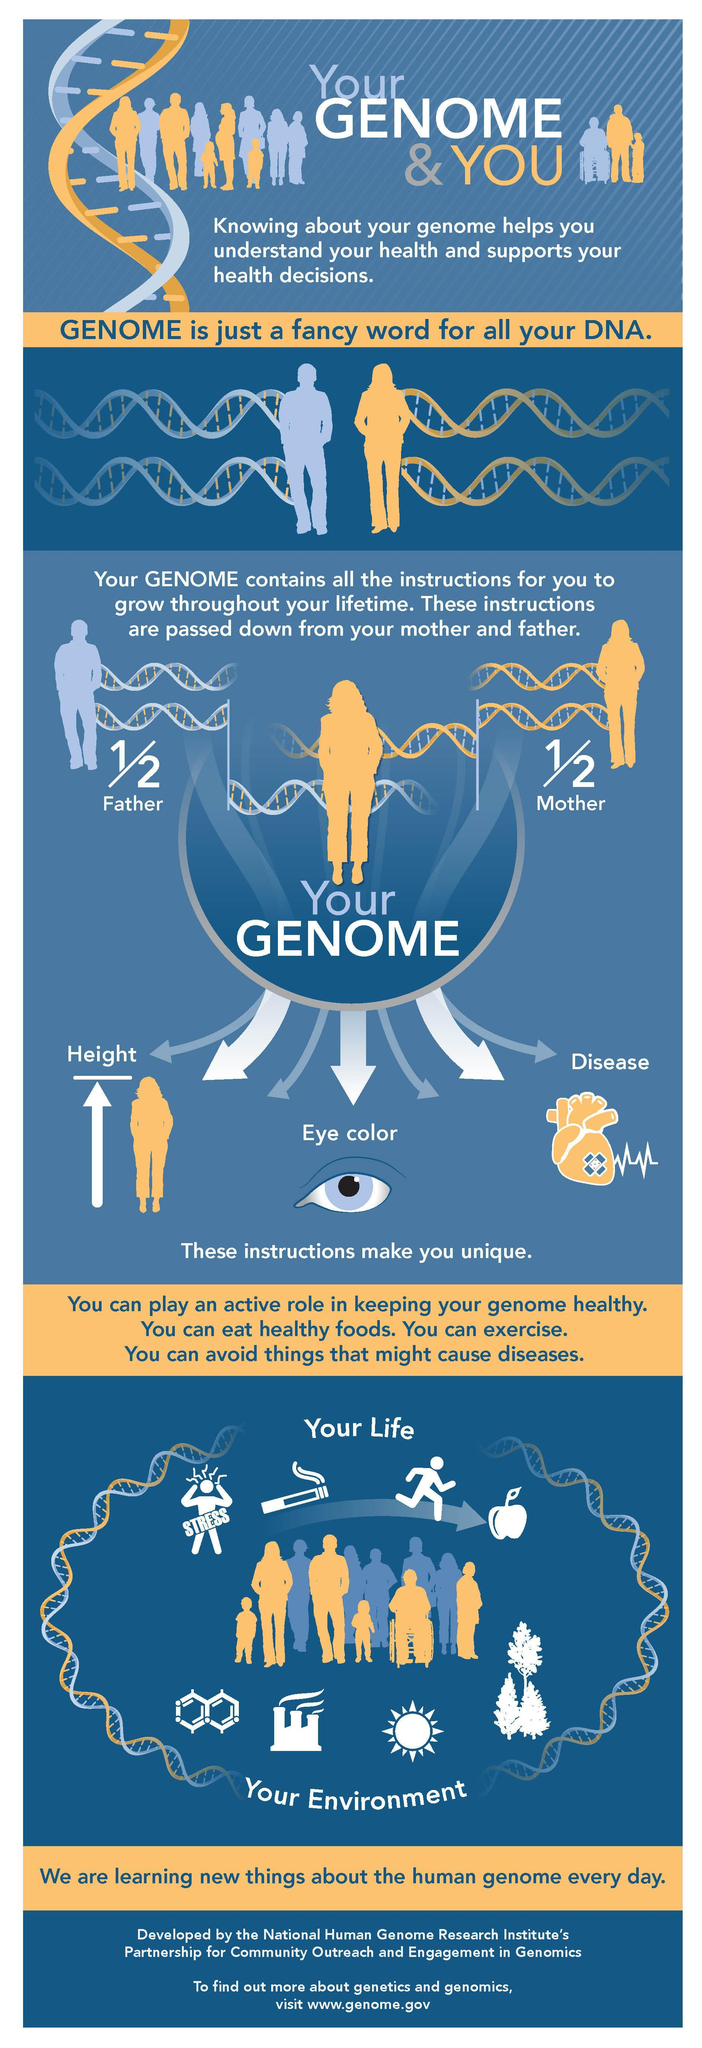What colors are predominantly used in the infographic?
Answer the question with a short phrase. Blue,yellow,white 